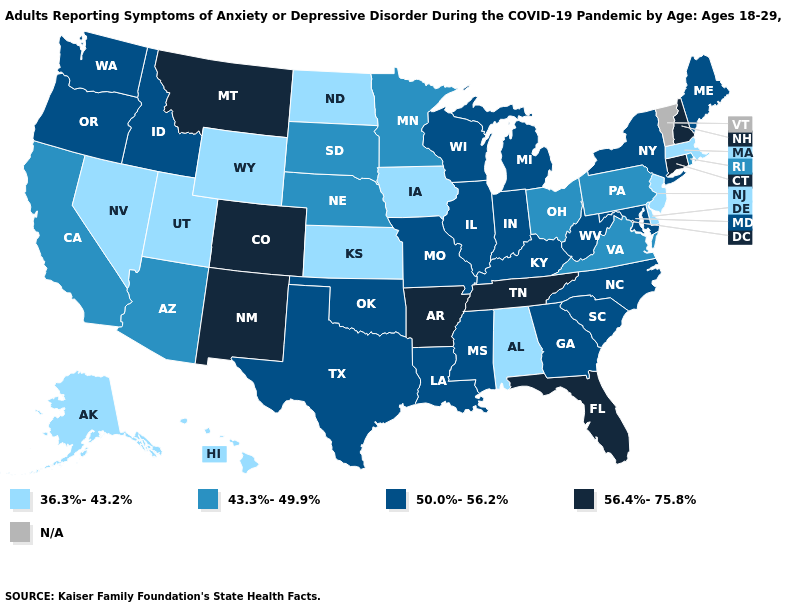Which states have the lowest value in the USA?
Short answer required. Alabama, Alaska, Delaware, Hawaii, Iowa, Kansas, Massachusetts, Nevada, New Jersey, North Dakota, Utah, Wyoming. Name the states that have a value in the range 36.3%-43.2%?
Concise answer only. Alabama, Alaska, Delaware, Hawaii, Iowa, Kansas, Massachusetts, Nevada, New Jersey, North Dakota, Utah, Wyoming. Is the legend a continuous bar?
Write a very short answer. No. What is the value of Texas?
Quick response, please. 50.0%-56.2%. What is the value of Florida?
Answer briefly. 56.4%-75.8%. Name the states that have a value in the range 43.3%-49.9%?
Give a very brief answer. Arizona, California, Minnesota, Nebraska, Ohio, Pennsylvania, Rhode Island, South Dakota, Virginia. Which states hav the highest value in the South?
Answer briefly. Arkansas, Florida, Tennessee. What is the value of North Dakota?
Concise answer only. 36.3%-43.2%. Is the legend a continuous bar?
Concise answer only. No. What is the lowest value in the USA?
Concise answer only. 36.3%-43.2%. What is the value of Maine?
Keep it brief. 50.0%-56.2%. Does Maine have the lowest value in the Northeast?
Quick response, please. No. Which states have the lowest value in the USA?
Concise answer only. Alabama, Alaska, Delaware, Hawaii, Iowa, Kansas, Massachusetts, Nevada, New Jersey, North Dakota, Utah, Wyoming. 